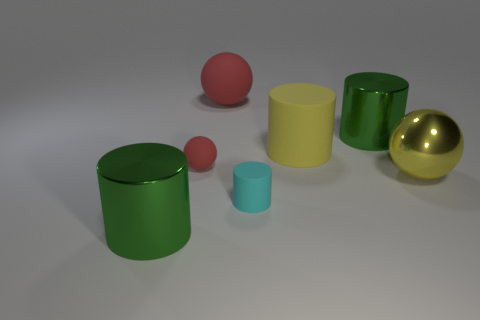Can you describe the colors and shapes of the objects in the image? Certainly! In the image, we have two green cylinders, one large and one small; a large yellow cylinder; a small red sphere; and a large shiny golden sphere. Additionally, there's a small cyan cylinder on the right-hand side. 